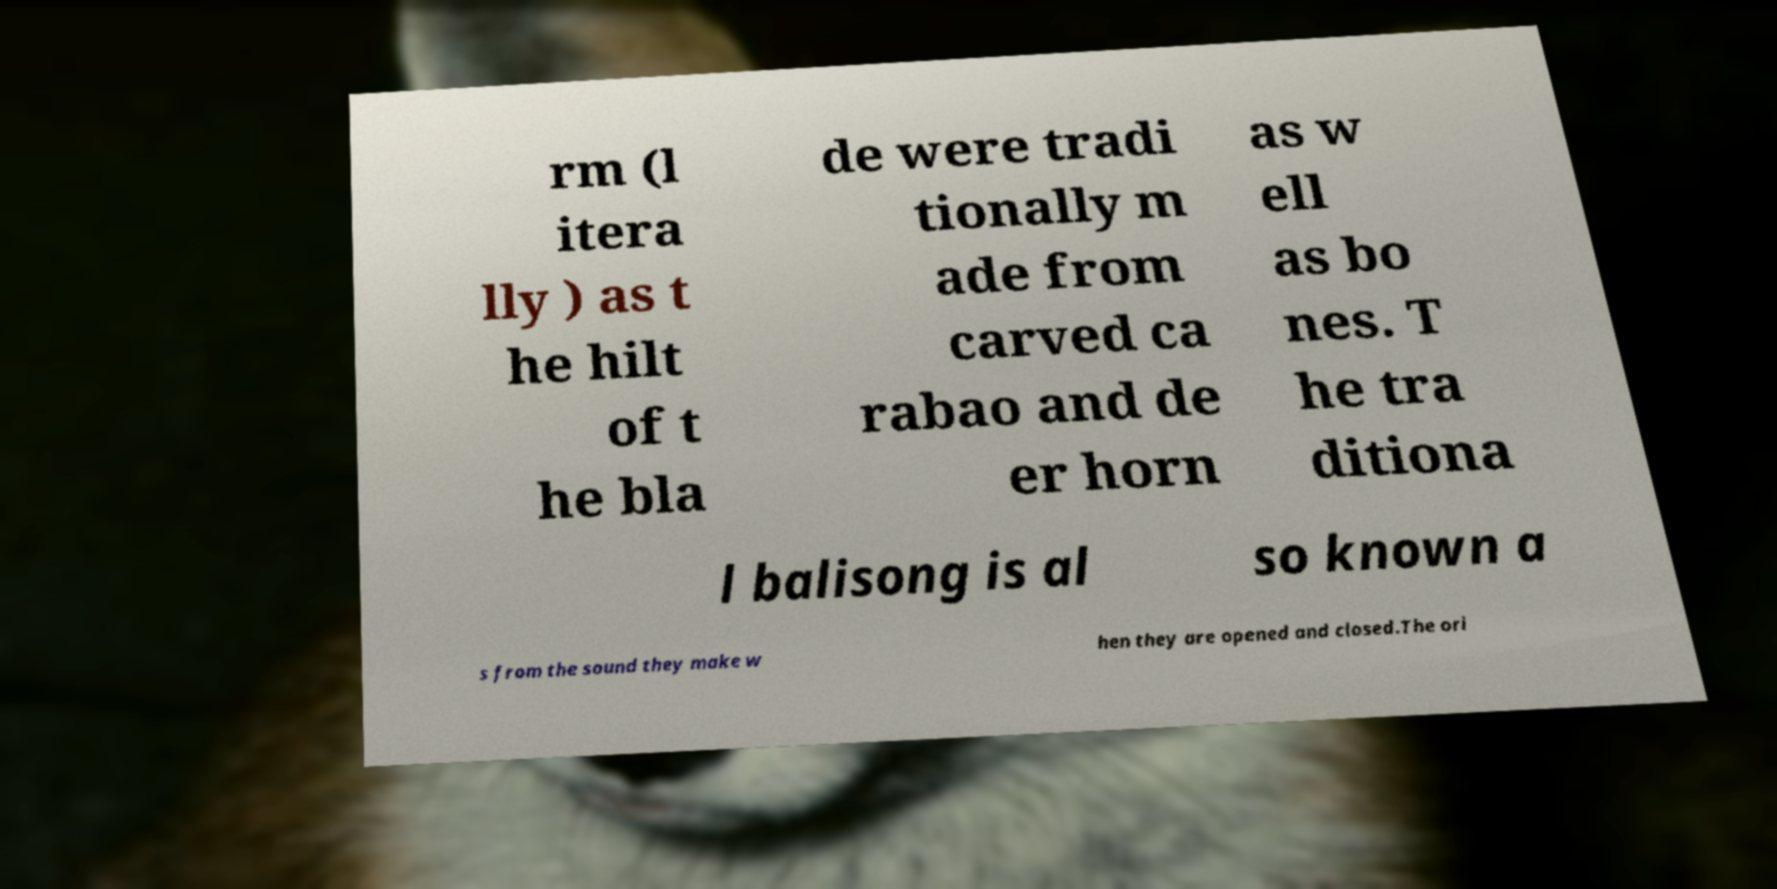There's text embedded in this image that I need extracted. Can you transcribe it verbatim? rm (l itera lly ) as t he hilt of t he bla de were tradi tionally m ade from carved ca rabao and de er horn as w ell as bo nes. T he tra ditiona l balisong is al so known a s from the sound they make w hen they are opened and closed.The ori 